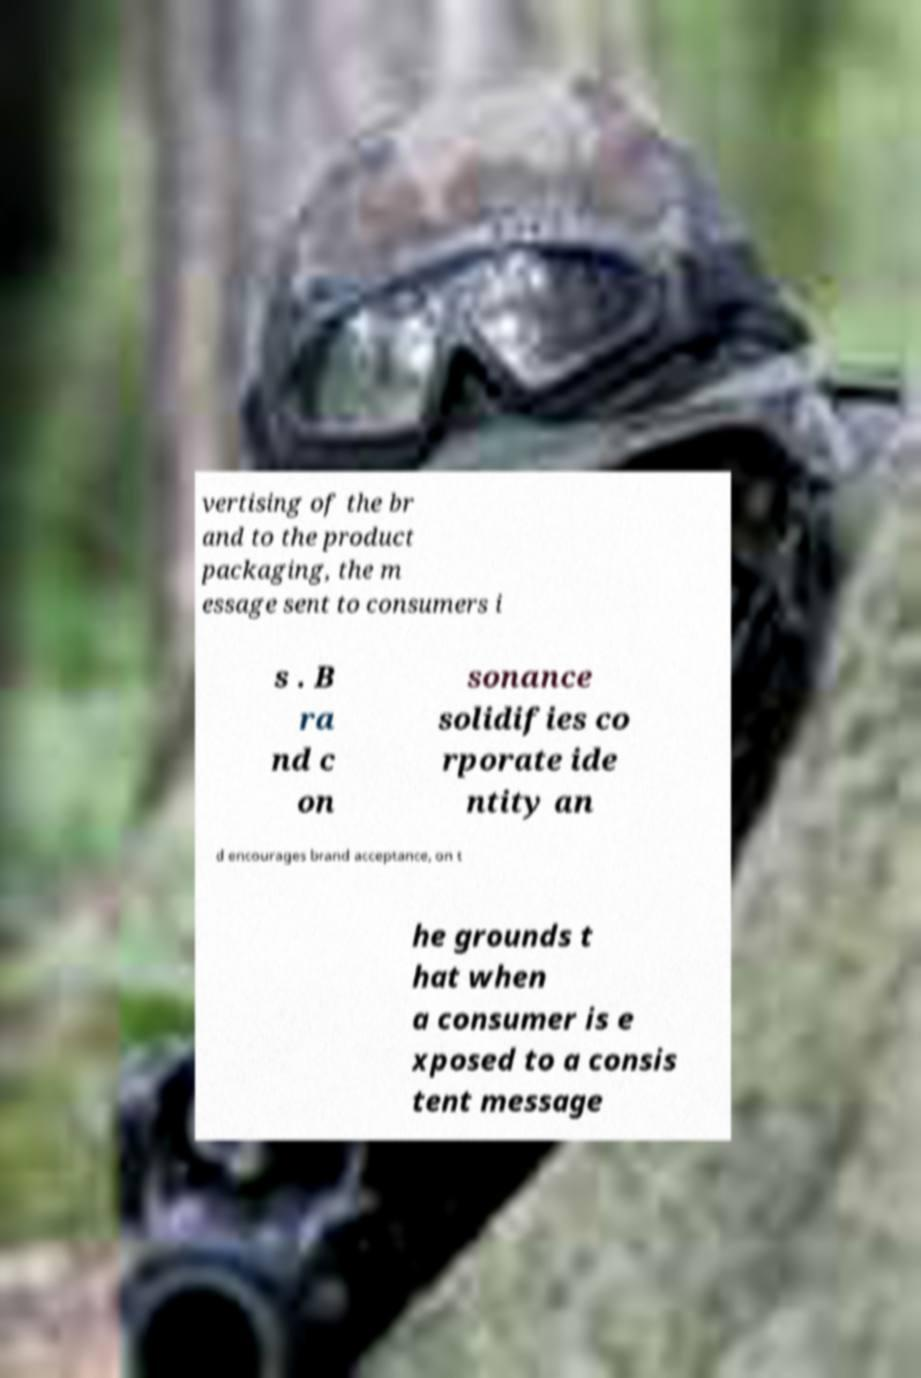Could you extract and type out the text from this image? vertising of the br and to the product packaging, the m essage sent to consumers i s . B ra nd c on sonance solidifies co rporate ide ntity an d encourages brand acceptance, on t he grounds t hat when a consumer is e xposed to a consis tent message 